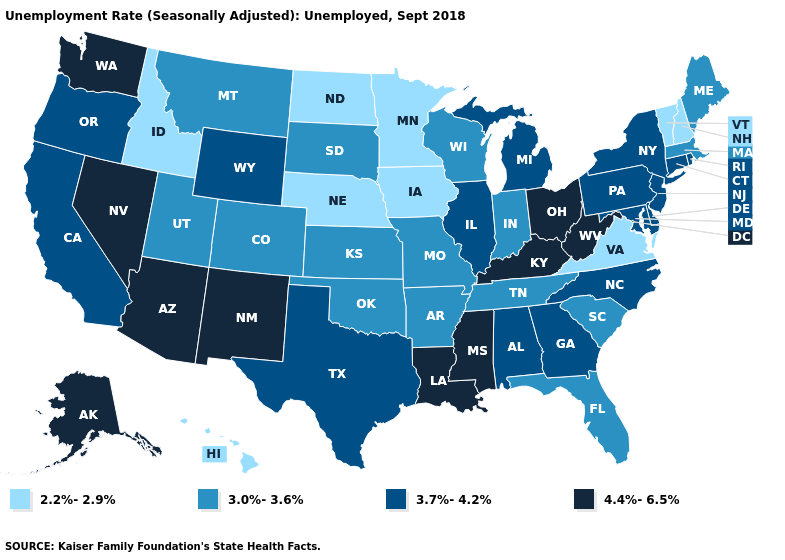Does the first symbol in the legend represent the smallest category?
Write a very short answer. Yes. Does the first symbol in the legend represent the smallest category?
Answer briefly. Yes. What is the value of Virginia?
Give a very brief answer. 2.2%-2.9%. Does Texas have the same value as Wyoming?
Short answer required. Yes. Does West Virginia have the same value as Kentucky?
Concise answer only. Yes. Which states hav the highest value in the West?
Short answer required. Alaska, Arizona, Nevada, New Mexico, Washington. Among the states that border Indiana , which have the highest value?
Concise answer only. Kentucky, Ohio. Does Texas have a lower value than Mississippi?
Write a very short answer. Yes. What is the value of Montana?
Be succinct. 3.0%-3.6%. Name the states that have a value in the range 2.2%-2.9%?
Give a very brief answer. Hawaii, Idaho, Iowa, Minnesota, Nebraska, New Hampshire, North Dakota, Vermont, Virginia. Does the map have missing data?
Quick response, please. No. Among the states that border Maryland , does Virginia have the lowest value?
Give a very brief answer. Yes. Does Vermont have the highest value in the Northeast?
Give a very brief answer. No. What is the value of California?
Answer briefly. 3.7%-4.2%. Does Hawaii have the lowest value in the USA?
Quick response, please. Yes. 